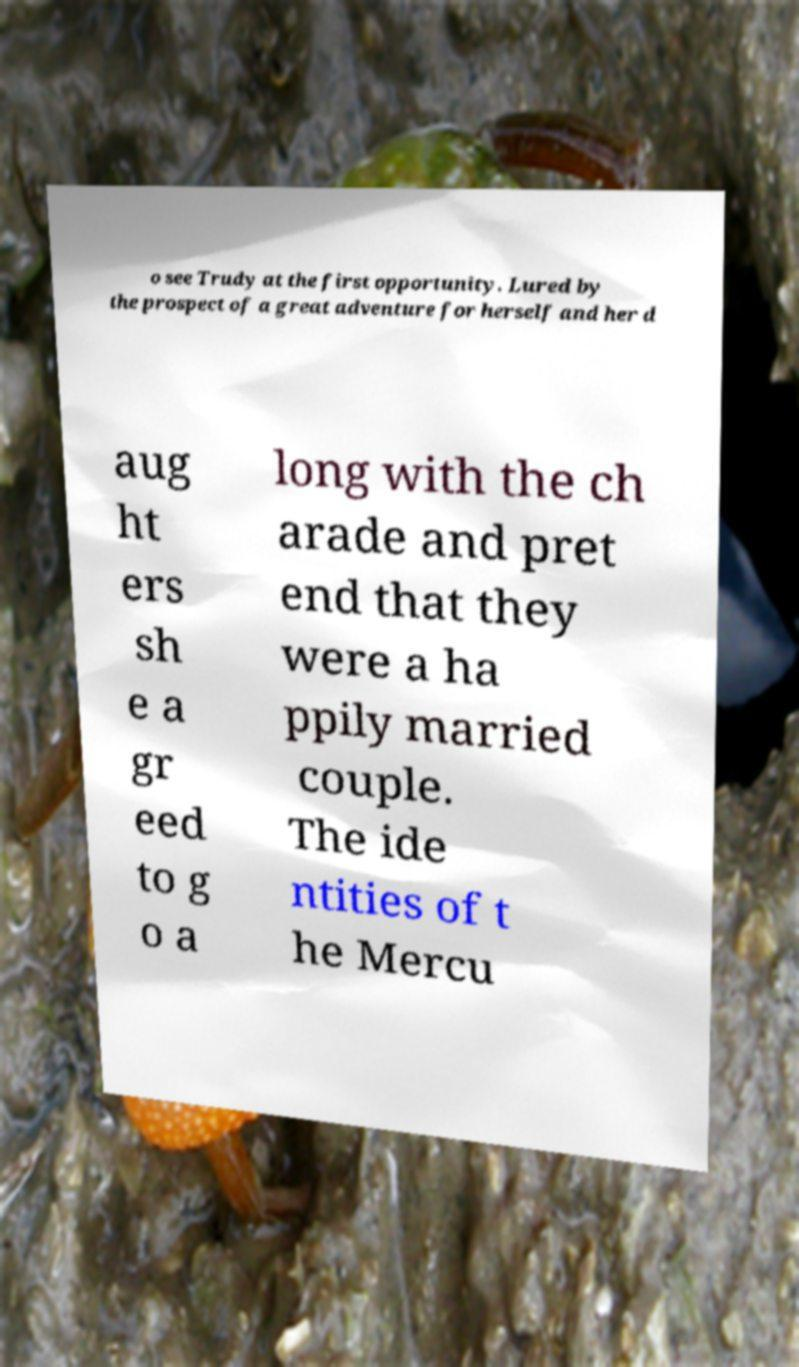For documentation purposes, I need the text within this image transcribed. Could you provide that? o see Trudy at the first opportunity. Lured by the prospect of a great adventure for herself and her d aug ht ers sh e a gr eed to g o a long with the ch arade and pret end that they were a ha ppily married couple. The ide ntities of t he Mercu 